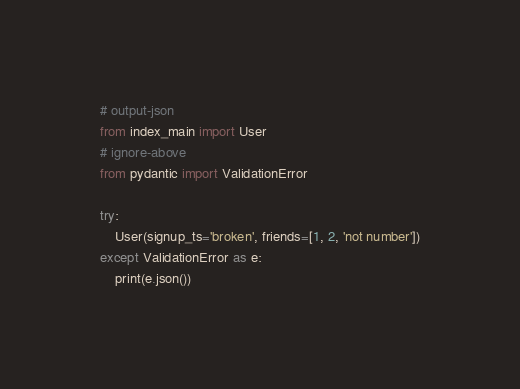Convert code to text. <code><loc_0><loc_0><loc_500><loc_500><_Python_># output-json
from index_main import User
# ignore-above
from pydantic import ValidationError

try:
    User(signup_ts='broken', friends=[1, 2, 'not number'])
except ValidationError as e:
    print(e.json())
</code> 